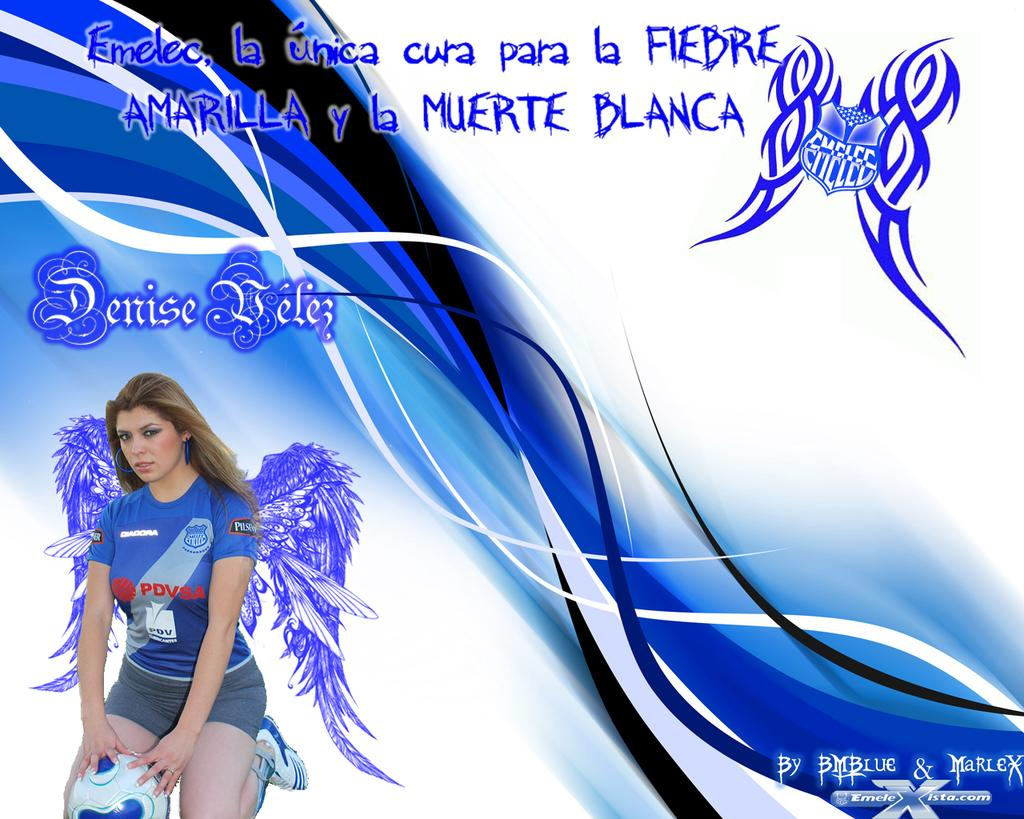<image>
Write a terse but informative summary of the picture. the word blanca that is on a sign 